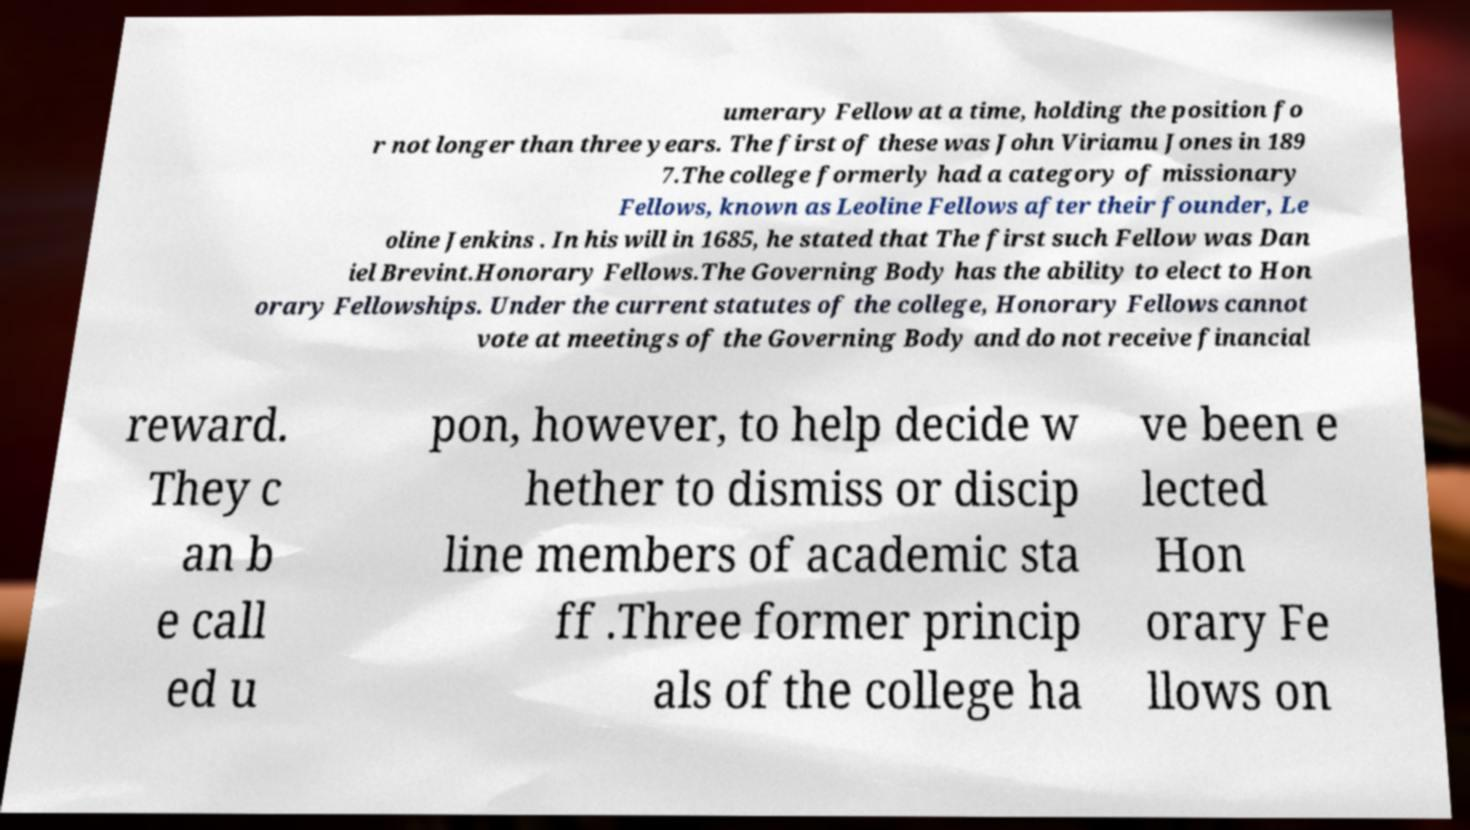Could you extract and type out the text from this image? umerary Fellow at a time, holding the position fo r not longer than three years. The first of these was John Viriamu Jones in 189 7.The college formerly had a category of missionary Fellows, known as Leoline Fellows after their founder, Le oline Jenkins . In his will in 1685, he stated that The first such Fellow was Dan iel Brevint.Honorary Fellows.The Governing Body has the ability to elect to Hon orary Fellowships. Under the current statutes of the college, Honorary Fellows cannot vote at meetings of the Governing Body and do not receive financial reward. They c an b e call ed u pon, however, to help decide w hether to dismiss or discip line members of academic sta ff .Three former princip als of the college ha ve been e lected Hon orary Fe llows on 